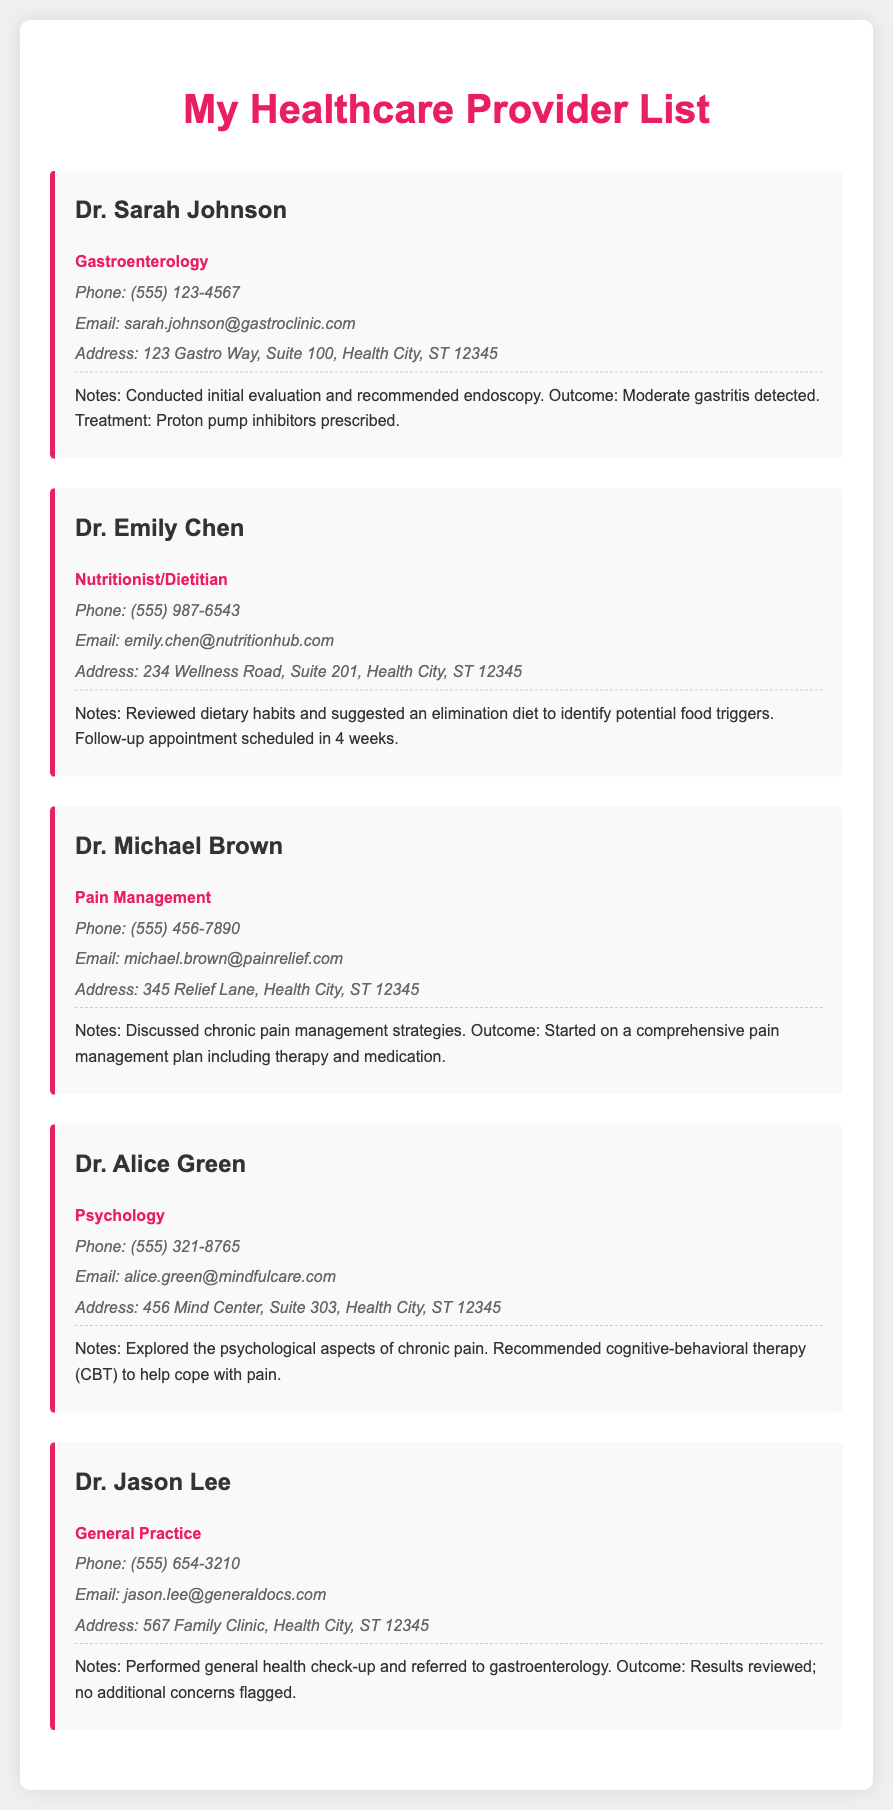What is the name of the gastroenterologist? The document lists Dr. Sarah Johnson as the gastroenterologist.
Answer: Dr. Sarah Johnson How many healthcare providers are listed? The document contains a total of five healthcare providers.
Answer: Five What specialty does Dr. Emily Chen practice? Dr. Emily Chen is a Nutritionist/Dietitian as stated in the document.
Answer: Nutritionist/Dietitian What was the outcome of the visit with Dr. Sarah Johnson? The outcome of the visit with Dr. Sarah Johnson was moderate gastritis detected.
Answer: Moderate gastritis detected Which provider recommended cognitive-behavioral therapy? Dr. Alice Green recommended cognitive-behavioral therapy according to the notes.
Answer: Dr. Alice Green What is Dr. Michael Brown's focus area? Dr. Michael Brown specializes in Pain Management as mentioned in the document.
Answer: Pain Management What treatment did Dr. Sarah Johnson prescribe? Dr. Sarah Johnson prescribed proton pump inhibitors for treatment.
Answer: Proton pump inhibitors What is the contact number for Dr. Jason Lee? The document provides the phone number for Dr. Jason Lee as (555) 654-3210.
Answer: (555) 654-3210 What was scheduled as a follow-up after visiting Dr. Emily Chen? A follow-up appointment was scheduled in 4 weeks after visiting Dr. Emily Chen.
Answer: Follow-up appointment in 4 weeks 